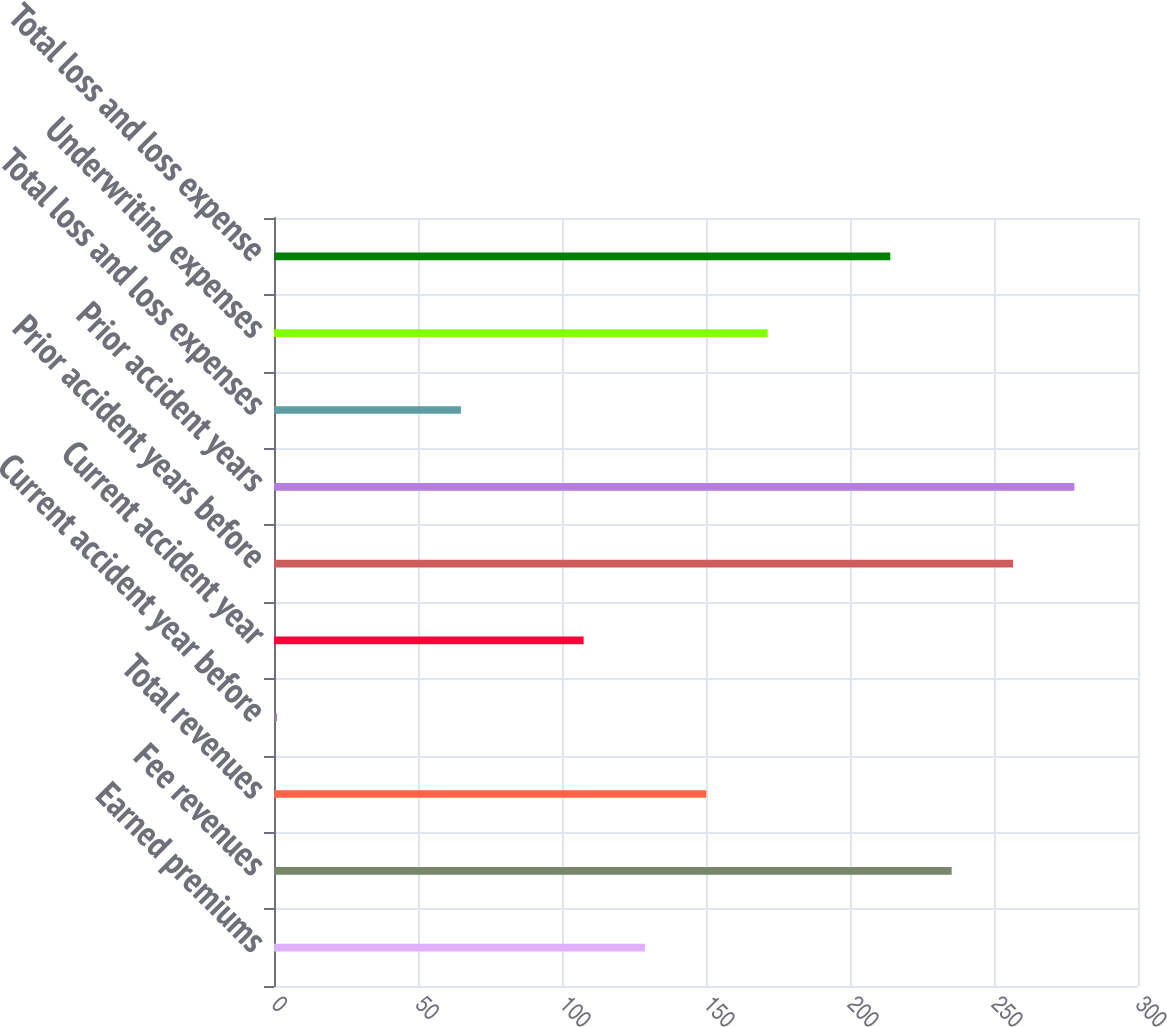<chart> <loc_0><loc_0><loc_500><loc_500><bar_chart><fcel>Earned premiums<fcel>Fee revenues<fcel>Total revenues<fcel>Current accident year before<fcel>Current accident year<fcel>Prior accident years before<fcel>Prior accident years<fcel>Total loss and loss expenses<fcel>Underwriting expenses<fcel>Total loss and loss expense<nl><fcel>128.8<fcel>235.3<fcel>150.1<fcel>1<fcel>107.5<fcel>256.6<fcel>277.9<fcel>64.9<fcel>171.4<fcel>214<nl></chart> 